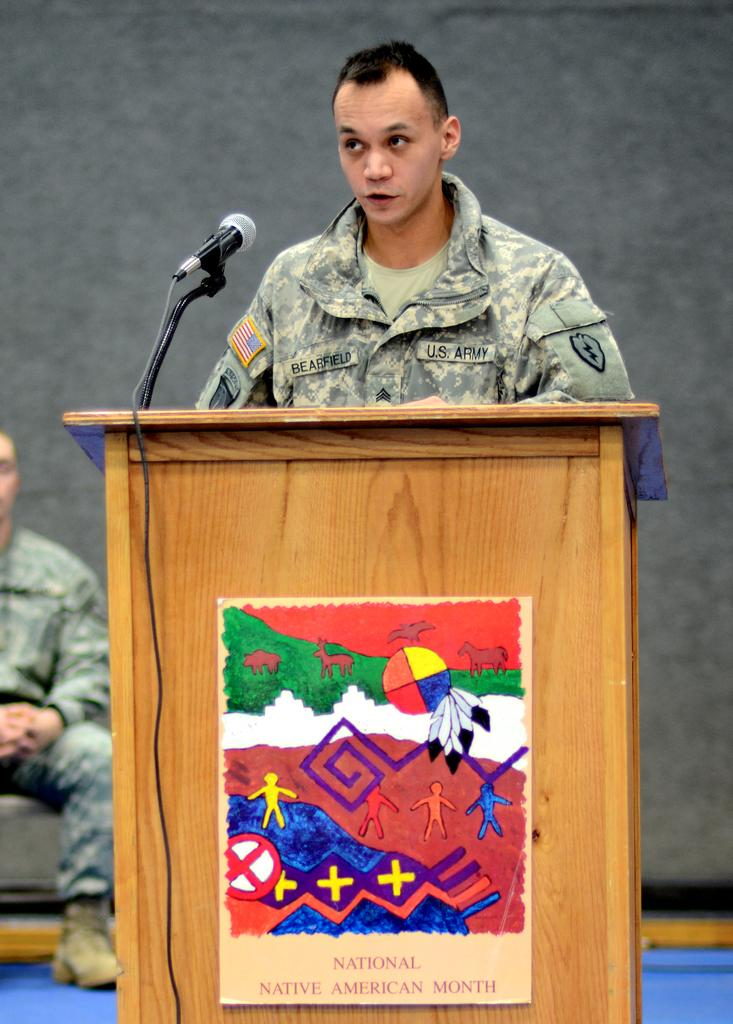Who is the main subject in the image? There is a man in the center of the image. What is the man in the image doing or standing near? The man is in front of a desk. What object is in front of the man? There is a mic in front of the man. Are there any other people in the image? Yes, there is another man on the left side of the image. What type of vein is visible on the man's sock in the image? There is no sock or vein visible on the man in the image. What kind of pets are present in the image? There are no pets present in the image. 